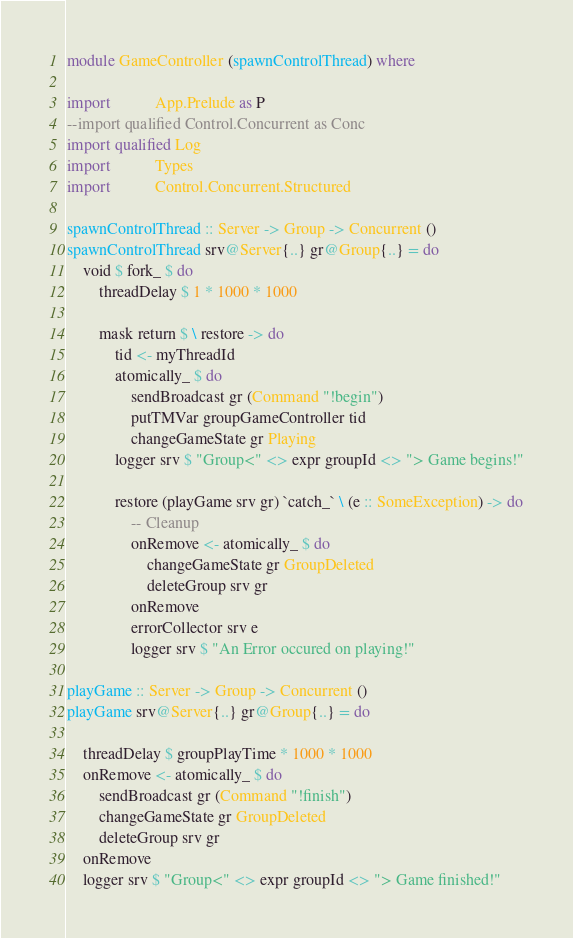Convert code to text. <code><loc_0><loc_0><loc_500><loc_500><_Haskell_>module GameController (spawnControlThread) where

import           App.Prelude as P
--import qualified Control.Concurrent as Conc
import qualified Log
import           Types
import           Control.Concurrent.Structured

spawnControlThread :: Server -> Group -> Concurrent ()
spawnControlThread srv@Server{..} gr@Group{..} = do
    void $ fork_ $ do
        threadDelay $ 1 * 1000 * 1000

        mask return $ \ restore -> do
            tid <- myThreadId
            atomically_ $ do
                sendBroadcast gr (Command "!begin")
                putTMVar groupGameController tid
                changeGameState gr Playing
            logger srv $ "Group<" <> expr groupId <> "> Game begins!"

            restore (playGame srv gr) `catch_` \ (e :: SomeException) -> do
                -- Cleanup
                onRemove <- atomically_ $ do
                    changeGameState gr GroupDeleted
                    deleteGroup srv gr
                onRemove
                errorCollector srv e
                logger srv $ "An Error occured on playing!"

playGame :: Server -> Group -> Concurrent ()
playGame srv@Server{..} gr@Group{..} = do

    threadDelay $ groupPlayTime * 1000 * 1000
    onRemove <- atomically_ $ do
        sendBroadcast gr (Command "!finish")
        changeGameState gr GroupDeleted
        deleteGroup srv gr
    onRemove
    logger srv $ "Group<" <> expr groupId <> "> Game finished!"
</code> 